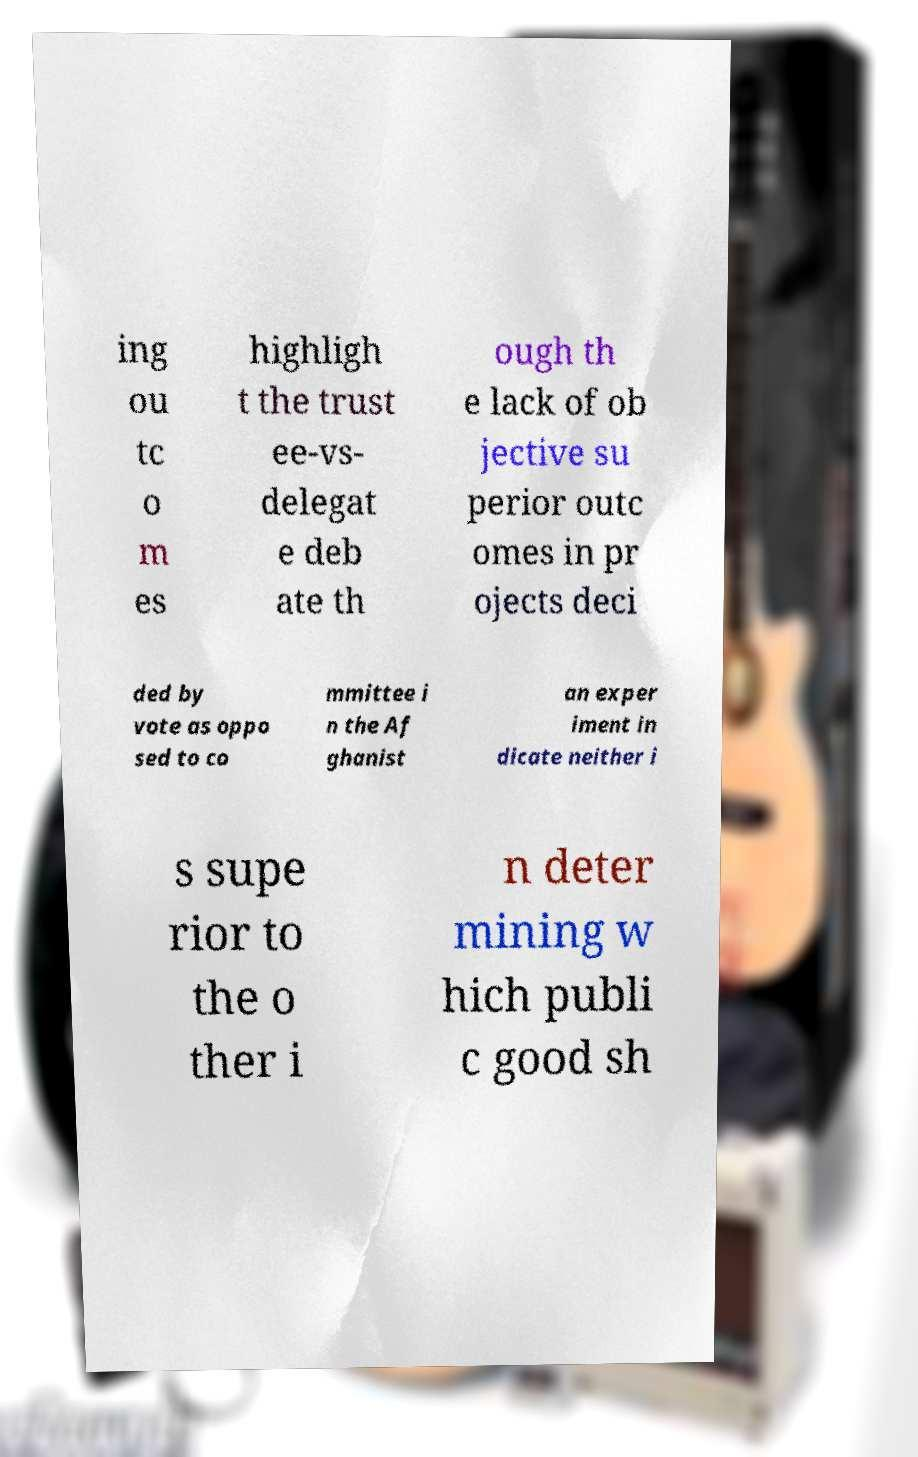Please read and relay the text visible in this image. What does it say? ing ou tc o m es highligh t the trust ee-vs- delegat e deb ate th ough th e lack of ob jective su perior outc omes in pr ojects deci ded by vote as oppo sed to co mmittee i n the Af ghanist an exper iment in dicate neither i s supe rior to the o ther i n deter mining w hich publi c good sh 